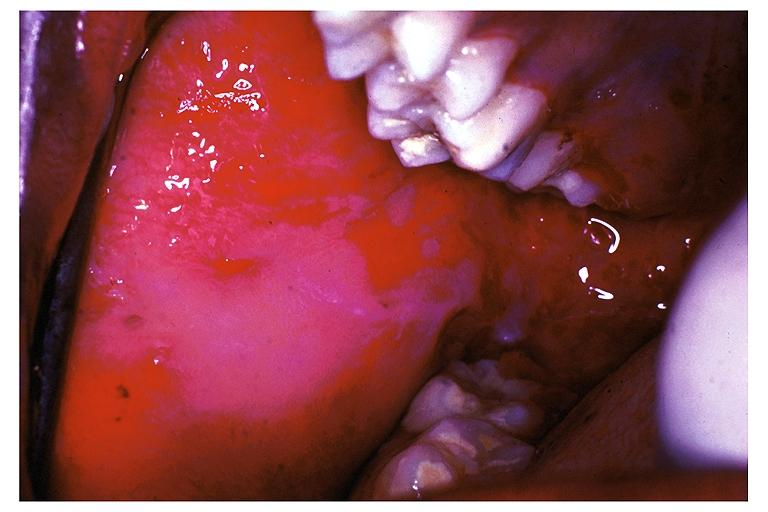does this image show pemphigus vulgaris?
Answer the question using a single word or phrase. Yes 